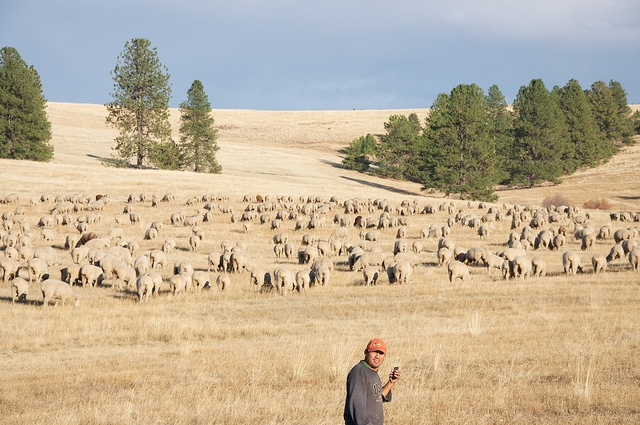Describe the objects in this image and their specific colors. I can see sheep in darkgray, tan, and beige tones, people in darkgray, gray, black, and salmon tones, sheep in darkgray, tan, and beige tones, sheep in darkgray, tan, and beige tones, and sheep in darkgray, tan, and maroon tones in this image. 